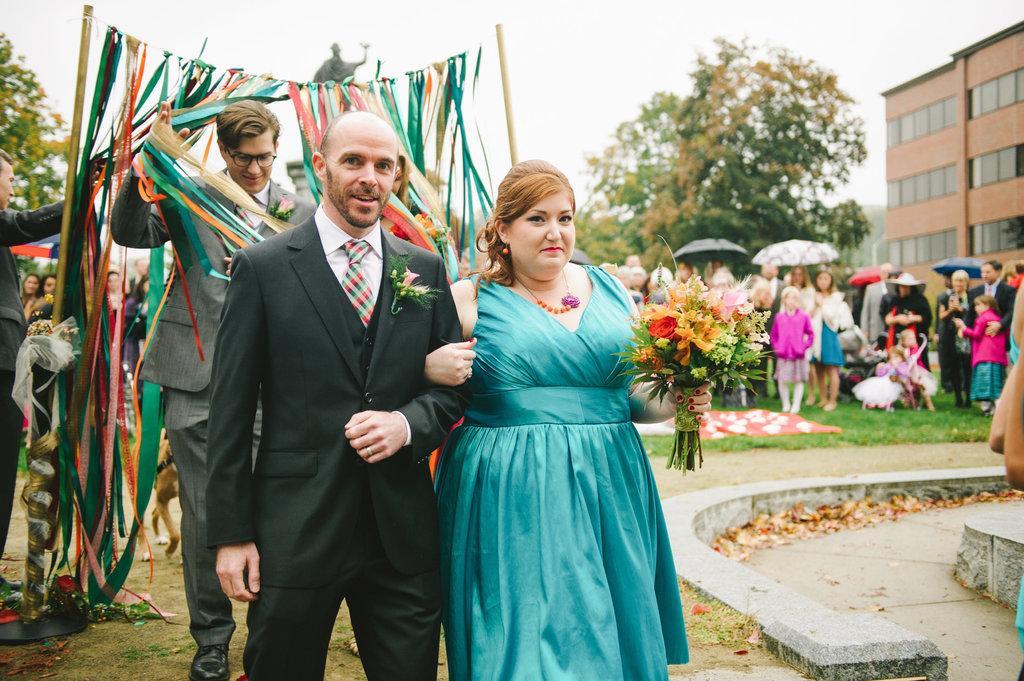Describe this image in one or two sentences. In this image we can see a group of people standing on the ground. One person is wearing black coat and a tie. One woman is wearing a dress and holding flowers in her hand. In the background, we can see a person wearing spectacles, ribbons, poles, a statue, group of trees, umbrellas, a building and the sky. 